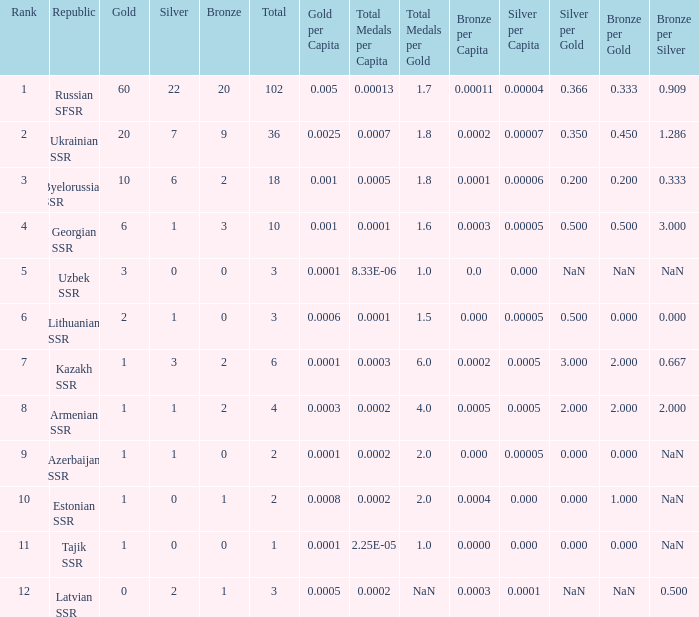What is the sum of silvers for teams with ranks over 3 and totals under 2? 0.0. Can you parse all the data within this table? {'header': ['Rank', 'Republic', 'Gold', 'Silver', 'Bronze', 'Total', 'Gold per Capita', 'Total Medals per Capita', 'Total Medals per Gold', 'Bronze per Capita', 'Silver per Capita', 'Silver per Gold', 'Bronze per Gold', 'Bronze per Silver '], 'rows': [['1', 'Russian SFSR', '60', '22', '20', '102', '0.005', '0.00013', '1.7', '0.00011', '0.00004', '0.366', '0.333', '0.909 '], ['2', 'Ukrainian SSR', '20', '7', '9', '36', '0.0025', '0.0007', '1.8', '0.0002', '0.00007', '0.350', '0.450', '1.286 '], ['3', 'Byelorussian SSR', '10', '6', '2', '18', '0.001', '0.0005', '1.8', '0.0001', '0.00006', '0.200', '0.200', '0.333 '], ['4', 'Georgian SSR', '6', '1', '3', '10', '0.001', '0.0001', '1.6', '0.0003', '0.00005', '0.500', '0.500', '3.000 '], ['5', 'Uzbek SSR', '3', '0', '0', '3', '0.0001', '8.33E-06', '1.0', '0.0', '0.000', 'NaN', 'NaN', 'NaN '], ['6', 'Lithuanian SSR', '2', '1', '0', '3', '0.0006', '0.0001', '1.5', '0.000', '0.00005', '0.500', '0.000', '0.000 '], ['7', 'Kazakh SSR', '1', '3', '2', '6', '0.0001', '0.0003', '6.0', '0.0002', '0.0005', '3.000', '2.000', '0.667 '], ['8', 'Armenian SSR', '1', '1', '2', '4', '0.0003', '0.0002', '4.0', '0.0005', '0.0005', '2.000', '2.000', '2.000 '], ['9', 'Azerbaijan SSR', '1', '1', '0', '2', '0.0001', '0.0002', '2.0', '0.000', '0.00005', '0.000', '0.000', 'NaN '], ['10', 'Estonian SSR', '1', '0', '1', '2', '0.0008', '0.0002', '2.0', '0.0004', '0.000', '0.000', '1.000', 'NaN '], ['11', 'Tajik SSR', '1', '0', '0', '1', '0.0001', '2.25E-05', '1.0', '0.0000', '0.000', '0.000', '0.000', 'NaN '], ['12', 'Latvian SSR', '0', '2', '1', '3', '0.0005', '0.0002', 'NaN', '0.0003', '0.0001', 'NaN', 'NaN', '0.500']]} 